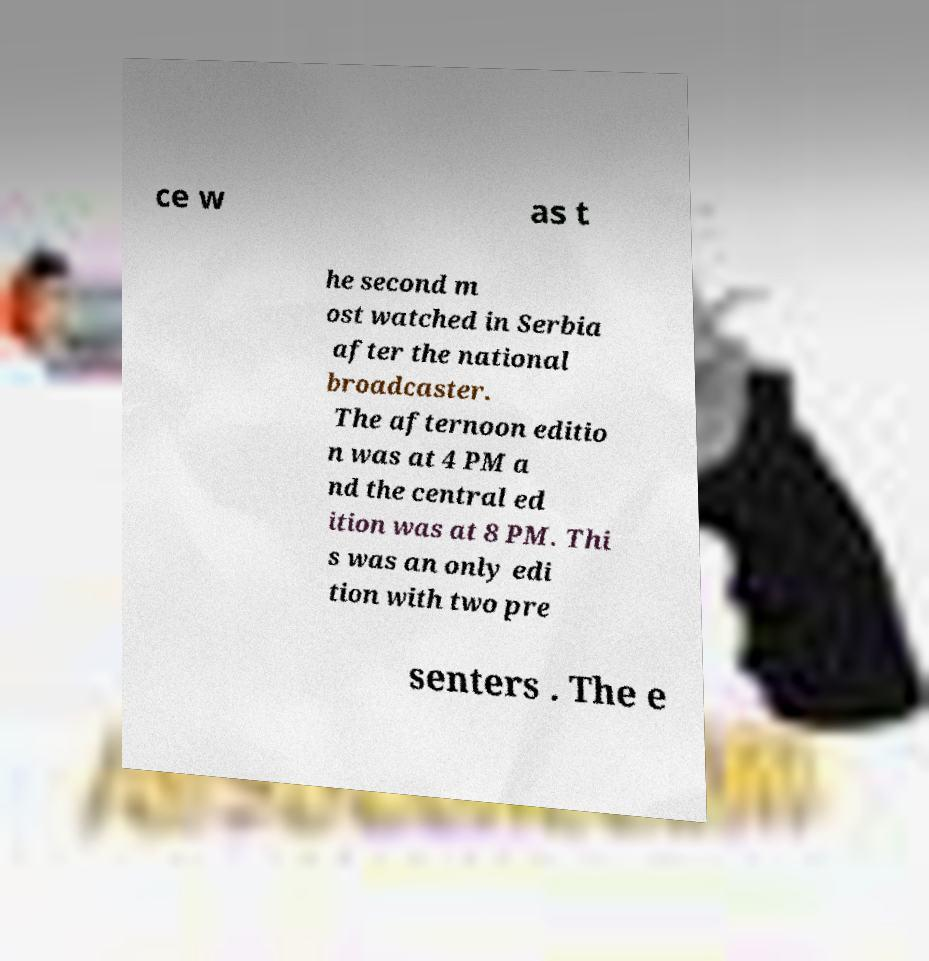For documentation purposes, I need the text within this image transcribed. Could you provide that? ce w as t he second m ost watched in Serbia after the national broadcaster. The afternoon editio n was at 4 PM a nd the central ed ition was at 8 PM. Thi s was an only edi tion with two pre senters . The e 